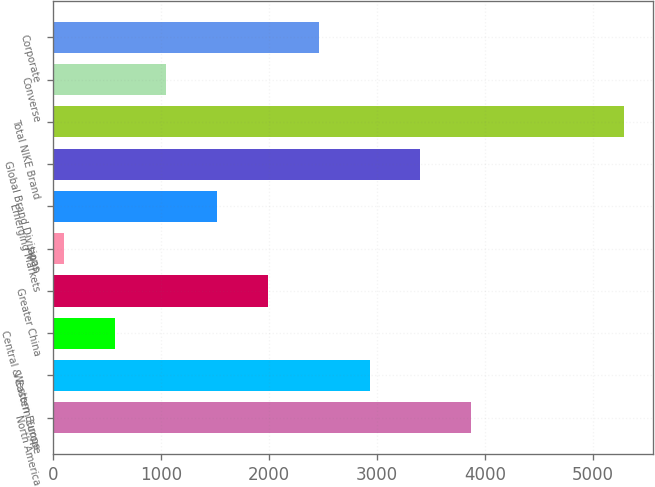<chart> <loc_0><loc_0><loc_500><loc_500><bar_chart><fcel>North America<fcel>Western Europe<fcel>Central & Eastern Europe<fcel>Greater China<fcel>Japan<fcel>Emerging Markets<fcel>Global Brand Divisions<fcel>Total NIKE Brand<fcel>Converse<fcel>Corporate<nl><fcel>3873.6<fcel>2930.2<fcel>571.7<fcel>1986.8<fcel>100<fcel>1515.1<fcel>3401.9<fcel>5288.7<fcel>1043.4<fcel>2458.5<nl></chart> 